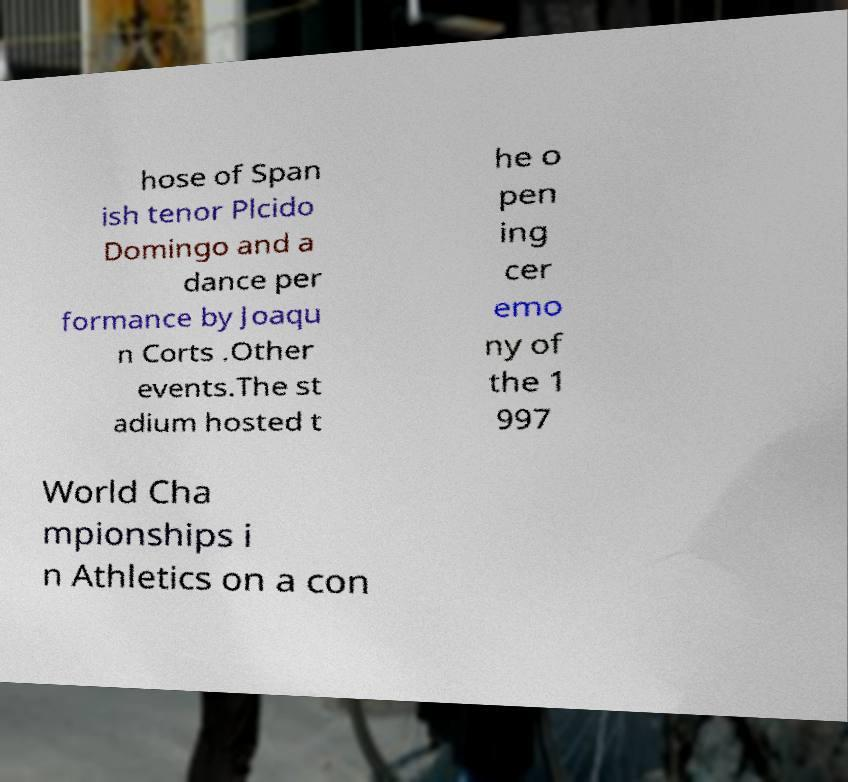Can you read and provide the text displayed in the image?This photo seems to have some interesting text. Can you extract and type it out for me? hose of Span ish tenor Plcido Domingo and a dance per formance by Joaqu n Corts .Other events.The st adium hosted t he o pen ing cer emo ny of the 1 997 World Cha mpionships i n Athletics on a con 